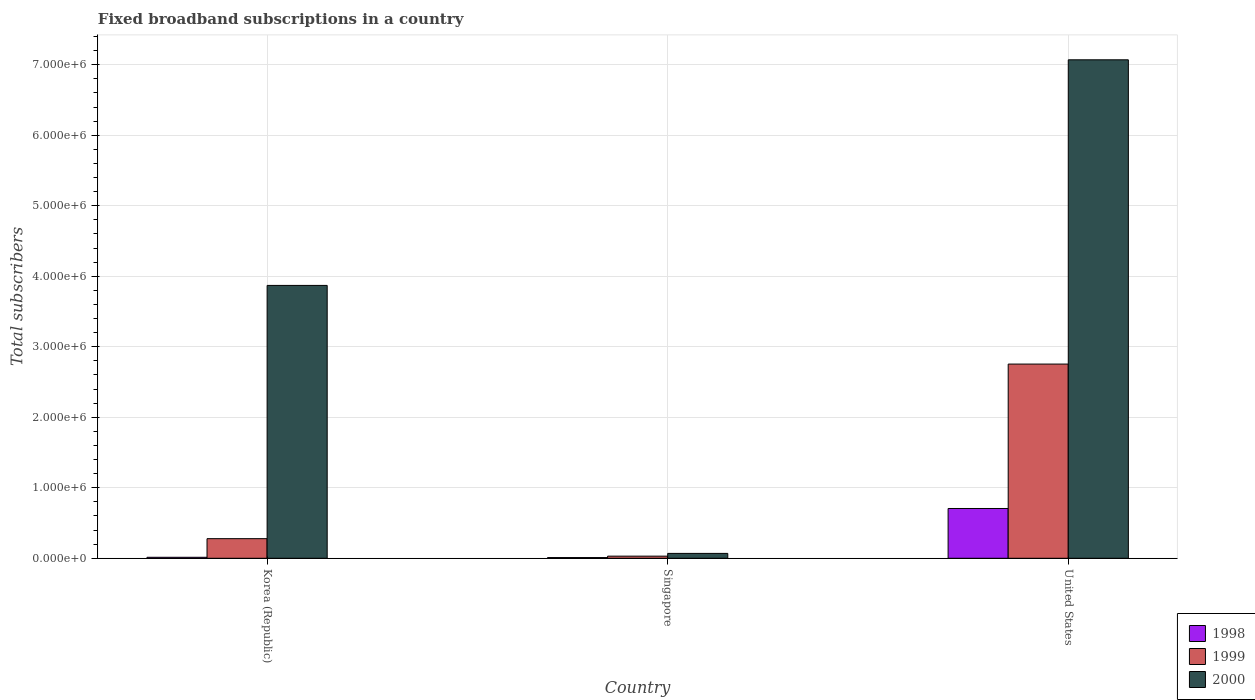How many different coloured bars are there?
Provide a short and direct response. 3. Are the number of bars per tick equal to the number of legend labels?
Keep it short and to the point. Yes. What is the label of the 3rd group of bars from the left?
Your response must be concise. United States. What is the number of broadband subscriptions in 1999 in Korea (Republic)?
Your answer should be very brief. 2.78e+05. Across all countries, what is the maximum number of broadband subscriptions in 2000?
Offer a very short reply. 7.07e+06. Across all countries, what is the minimum number of broadband subscriptions in 1999?
Keep it short and to the point. 3.00e+04. In which country was the number of broadband subscriptions in 1998 maximum?
Offer a terse response. United States. In which country was the number of broadband subscriptions in 1998 minimum?
Your response must be concise. Singapore. What is the total number of broadband subscriptions in 2000 in the graph?
Your answer should be very brief. 1.10e+07. What is the difference between the number of broadband subscriptions in 1999 in Korea (Republic) and that in United States?
Your response must be concise. -2.48e+06. What is the difference between the number of broadband subscriptions in 2000 in United States and the number of broadband subscriptions in 1998 in Singapore?
Your answer should be very brief. 7.06e+06. What is the average number of broadband subscriptions in 1998 per country?
Your answer should be very brief. 2.43e+05. What is the difference between the number of broadband subscriptions of/in 2000 and number of broadband subscriptions of/in 1999 in Singapore?
Keep it short and to the point. 3.90e+04. In how many countries, is the number of broadband subscriptions in 2000 greater than 1400000?
Provide a short and direct response. 2. What is the ratio of the number of broadband subscriptions in 1998 in Singapore to that in United States?
Offer a very short reply. 0.01. Is the difference between the number of broadband subscriptions in 2000 in Korea (Republic) and United States greater than the difference between the number of broadband subscriptions in 1999 in Korea (Republic) and United States?
Make the answer very short. No. What is the difference between the highest and the second highest number of broadband subscriptions in 2000?
Keep it short and to the point. -3.20e+06. What is the difference between the highest and the lowest number of broadband subscriptions in 1998?
Your response must be concise. 6.96e+05. In how many countries, is the number of broadband subscriptions in 2000 greater than the average number of broadband subscriptions in 2000 taken over all countries?
Provide a short and direct response. 2. Is the sum of the number of broadband subscriptions in 2000 in Korea (Republic) and Singapore greater than the maximum number of broadband subscriptions in 1999 across all countries?
Ensure brevity in your answer.  Yes. What does the 1st bar from the left in Singapore represents?
Your answer should be compact. 1998. How many countries are there in the graph?
Keep it short and to the point. 3. What is the difference between two consecutive major ticks on the Y-axis?
Offer a very short reply. 1.00e+06. How many legend labels are there?
Give a very brief answer. 3. How are the legend labels stacked?
Keep it short and to the point. Vertical. What is the title of the graph?
Your response must be concise. Fixed broadband subscriptions in a country. What is the label or title of the Y-axis?
Provide a succinct answer. Total subscribers. What is the Total subscribers in 1998 in Korea (Republic)?
Make the answer very short. 1.40e+04. What is the Total subscribers in 1999 in Korea (Republic)?
Ensure brevity in your answer.  2.78e+05. What is the Total subscribers in 2000 in Korea (Republic)?
Your response must be concise. 3.87e+06. What is the Total subscribers in 2000 in Singapore?
Ensure brevity in your answer.  6.90e+04. What is the Total subscribers in 1998 in United States?
Offer a terse response. 7.06e+05. What is the Total subscribers of 1999 in United States?
Ensure brevity in your answer.  2.75e+06. What is the Total subscribers in 2000 in United States?
Provide a short and direct response. 7.07e+06. Across all countries, what is the maximum Total subscribers in 1998?
Offer a very short reply. 7.06e+05. Across all countries, what is the maximum Total subscribers in 1999?
Your response must be concise. 2.75e+06. Across all countries, what is the maximum Total subscribers in 2000?
Your response must be concise. 7.07e+06. Across all countries, what is the minimum Total subscribers in 1998?
Your response must be concise. 10000. Across all countries, what is the minimum Total subscribers in 1999?
Offer a terse response. 3.00e+04. Across all countries, what is the minimum Total subscribers in 2000?
Offer a terse response. 6.90e+04. What is the total Total subscribers in 1998 in the graph?
Provide a succinct answer. 7.30e+05. What is the total Total subscribers of 1999 in the graph?
Provide a succinct answer. 3.06e+06. What is the total Total subscribers in 2000 in the graph?
Give a very brief answer. 1.10e+07. What is the difference between the Total subscribers of 1998 in Korea (Republic) and that in Singapore?
Ensure brevity in your answer.  4000. What is the difference between the Total subscribers of 1999 in Korea (Republic) and that in Singapore?
Make the answer very short. 2.48e+05. What is the difference between the Total subscribers in 2000 in Korea (Republic) and that in Singapore?
Offer a very short reply. 3.80e+06. What is the difference between the Total subscribers of 1998 in Korea (Republic) and that in United States?
Offer a very short reply. -6.92e+05. What is the difference between the Total subscribers in 1999 in Korea (Republic) and that in United States?
Make the answer very short. -2.48e+06. What is the difference between the Total subscribers of 2000 in Korea (Republic) and that in United States?
Provide a succinct answer. -3.20e+06. What is the difference between the Total subscribers of 1998 in Singapore and that in United States?
Offer a very short reply. -6.96e+05. What is the difference between the Total subscribers of 1999 in Singapore and that in United States?
Ensure brevity in your answer.  -2.72e+06. What is the difference between the Total subscribers in 2000 in Singapore and that in United States?
Your answer should be very brief. -7.00e+06. What is the difference between the Total subscribers of 1998 in Korea (Republic) and the Total subscribers of 1999 in Singapore?
Offer a terse response. -1.60e+04. What is the difference between the Total subscribers of 1998 in Korea (Republic) and the Total subscribers of 2000 in Singapore?
Your answer should be very brief. -5.50e+04. What is the difference between the Total subscribers in 1999 in Korea (Republic) and the Total subscribers in 2000 in Singapore?
Your answer should be compact. 2.09e+05. What is the difference between the Total subscribers of 1998 in Korea (Republic) and the Total subscribers of 1999 in United States?
Provide a succinct answer. -2.74e+06. What is the difference between the Total subscribers of 1998 in Korea (Republic) and the Total subscribers of 2000 in United States?
Make the answer very short. -7.06e+06. What is the difference between the Total subscribers of 1999 in Korea (Republic) and the Total subscribers of 2000 in United States?
Your answer should be compact. -6.79e+06. What is the difference between the Total subscribers in 1998 in Singapore and the Total subscribers in 1999 in United States?
Offer a very short reply. -2.74e+06. What is the difference between the Total subscribers in 1998 in Singapore and the Total subscribers in 2000 in United States?
Your response must be concise. -7.06e+06. What is the difference between the Total subscribers of 1999 in Singapore and the Total subscribers of 2000 in United States?
Your response must be concise. -7.04e+06. What is the average Total subscribers in 1998 per country?
Your answer should be compact. 2.43e+05. What is the average Total subscribers in 1999 per country?
Make the answer very short. 1.02e+06. What is the average Total subscribers of 2000 per country?
Ensure brevity in your answer.  3.67e+06. What is the difference between the Total subscribers of 1998 and Total subscribers of 1999 in Korea (Republic)?
Your response must be concise. -2.64e+05. What is the difference between the Total subscribers of 1998 and Total subscribers of 2000 in Korea (Republic)?
Provide a succinct answer. -3.86e+06. What is the difference between the Total subscribers in 1999 and Total subscribers in 2000 in Korea (Republic)?
Provide a short and direct response. -3.59e+06. What is the difference between the Total subscribers in 1998 and Total subscribers in 2000 in Singapore?
Your answer should be very brief. -5.90e+04. What is the difference between the Total subscribers in 1999 and Total subscribers in 2000 in Singapore?
Make the answer very short. -3.90e+04. What is the difference between the Total subscribers of 1998 and Total subscribers of 1999 in United States?
Your answer should be compact. -2.05e+06. What is the difference between the Total subscribers of 1998 and Total subscribers of 2000 in United States?
Provide a succinct answer. -6.36e+06. What is the difference between the Total subscribers in 1999 and Total subscribers in 2000 in United States?
Ensure brevity in your answer.  -4.32e+06. What is the ratio of the Total subscribers in 1998 in Korea (Republic) to that in Singapore?
Provide a short and direct response. 1.4. What is the ratio of the Total subscribers of 1999 in Korea (Republic) to that in Singapore?
Keep it short and to the point. 9.27. What is the ratio of the Total subscribers in 2000 in Korea (Republic) to that in Singapore?
Your answer should be compact. 56.09. What is the ratio of the Total subscribers of 1998 in Korea (Republic) to that in United States?
Give a very brief answer. 0.02. What is the ratio of the Total subscribers of 1999 in Korea (Republic) to that in United States?
Make the answer very short. 0.1. What is the ratio of the Total subscribers of 2000 in Korea (Republic) to that in United States?
Give a very brief answer. 0.55. What is the ratio of the Total subscribers of 1998 in Singapore to that in United States?
Make the answer very short. 0.01. What is the ratio of the Total subscribers in 1999 in Singapore to that in United States?
Your answer should be very brief. 0.01. What is the ratio of the Total subscribers in 2000 in Singapore to that in United States?
Provide a succinct answer. 0.01. What is the difference between the highest and the second highest Total subscribers of 1998?
Provide a short and direct response. 6.92e+05. What is the difference between the highest and the second highest Total subscribers in 1999?
Ensure brevity in your answer.  2.48e+06. What is the difference between the highest and the second highest Total subscribers in 2000?
Offer a very short reply. 3.20e+06. What is the difference between the highest and the lowest Total subscribers of 1998?
Provide a short and direct response. 6.96e+05. What is the difference between the highest and the lowest Total subscribers of 1999?
Make the answer very short. 2.72e+06. What is the difference between the highest and the lowest Total subscribers of 2000?
Keep it short and to the point. 7.00e+06. 